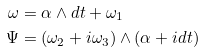Convert formula to latex. <formula><loc_0><loc_0><loc_500><loc_500>\omega & = \alpha \wedge d t + \omega _ { 1 } \\ \Psi & = ( \omega _ { 2 } + i \omega _ { 3 } ) \wedge ( \alpha + i d t )</formula> 